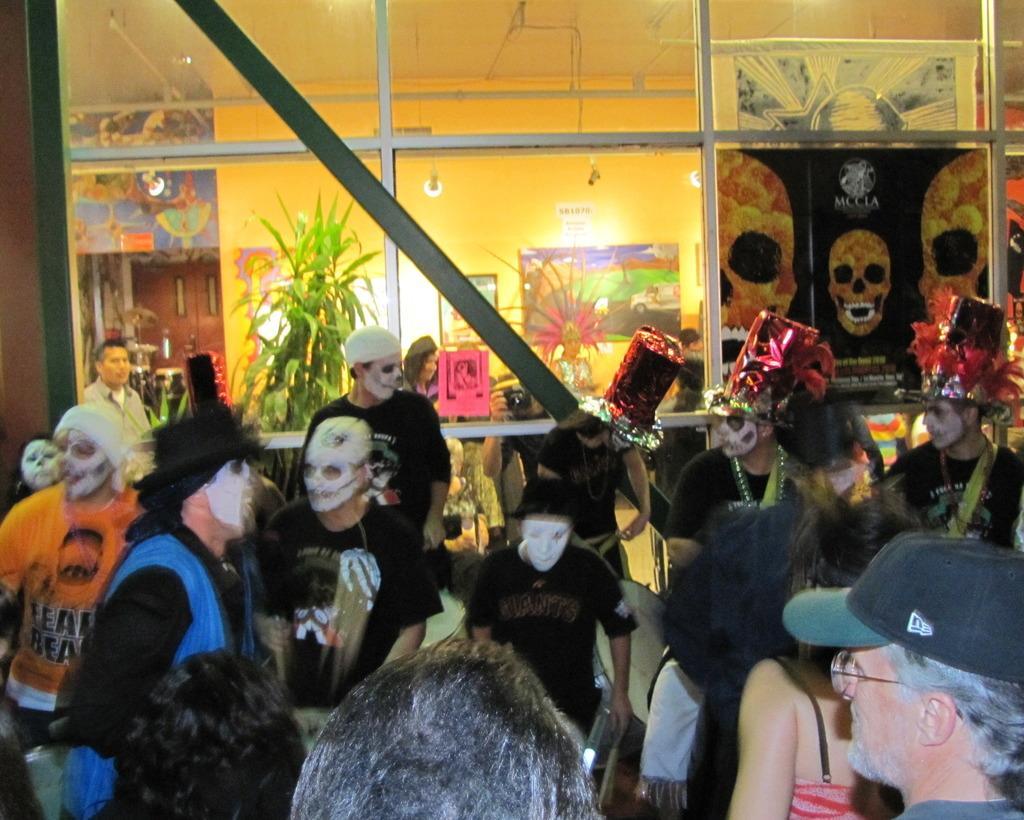Describe this image in one or two sentences. In this picture, we see the people who are wearing the face masks are standing. At the bottom, we see a man is wearing the spectacles and a cap. Behind them, we see the glass door or a window from which we can see the flower pots and two people are standing. We even see a wall on which posters and photo frames are placed. On the left side, we see a door. On the right side, we see a board or a poster in black color is pasted on the glass door. 